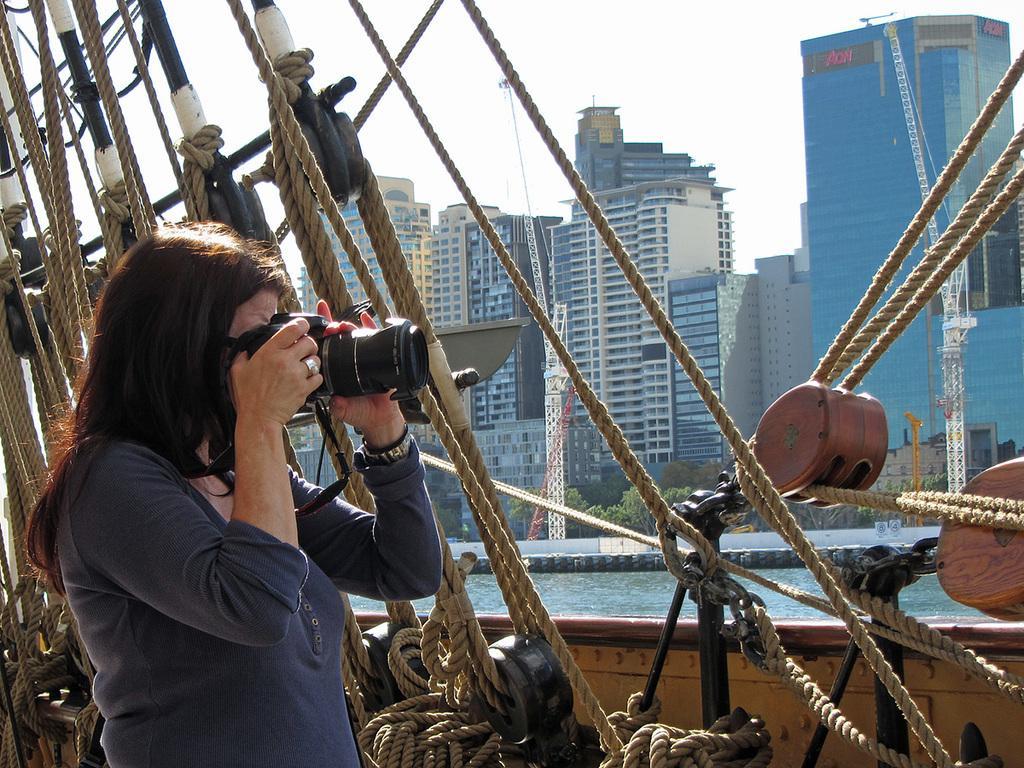In one or two sentences, can you explain what this image depicts? In this image we can see a lady taking picture using the camera, she is on the ship, there are ropes, poles, there are buildings, windows, trees, plants, also we can see the water, and the sky. 